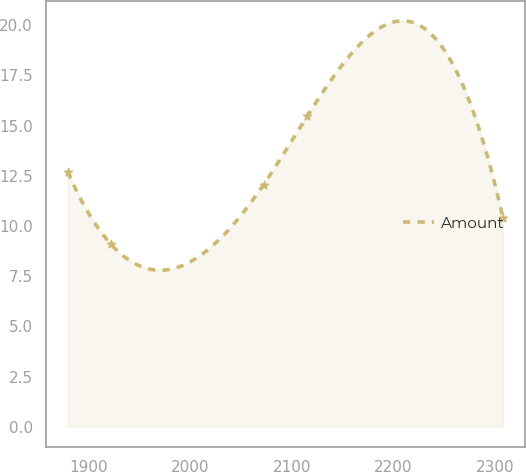Convert chart to OTSL. <chart><loc_0><loc_0><loc_500><loc_500><line_chart><ecel><fcel>Amount<nl><fcel>1879.35<fcel>12.7<nl><fcel>1922.21<fcel>9.08<nl><fcel>2072.26<fcel>12.06<nl><fcel>2115.12<fcel>15.46<nl><fcel>2307.94<fcel>10.42<nl></chart> 